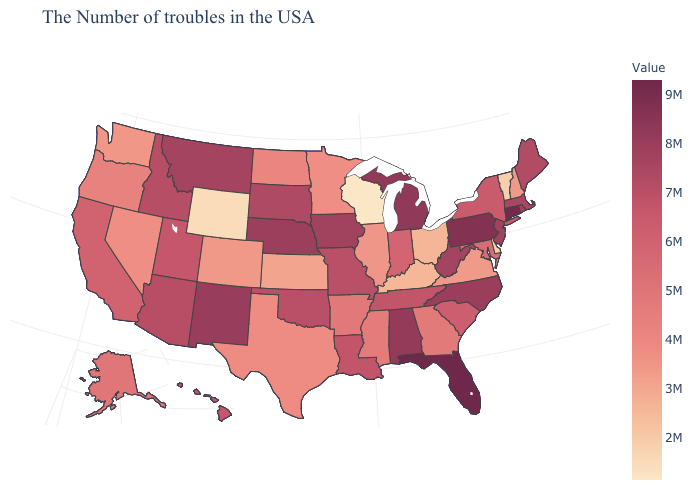Which states have the highest value in the USA?
Short answer required. Florida. Which states hav the highest value in the West?
Be succinct. New Mexico. Does Wisconsin have the lowest value in the USA?
Be succinct. Yes. Is the legend a continuous bar?
Keep it brief. Yes. 